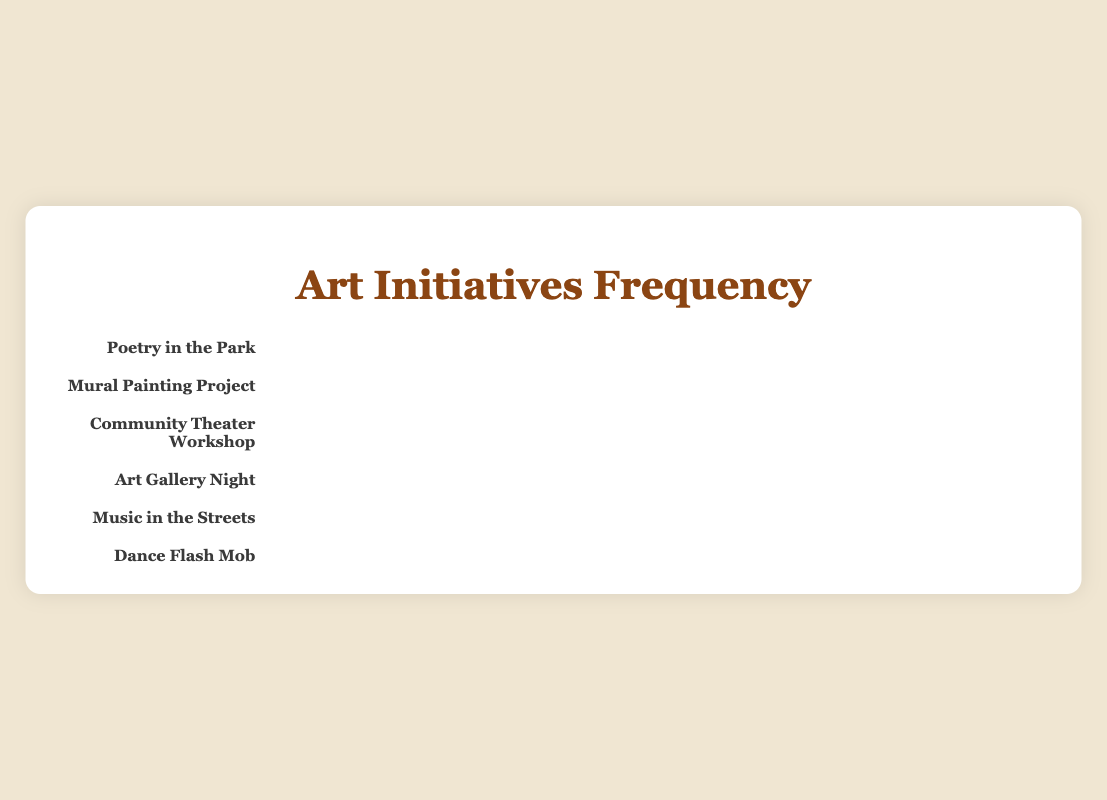What's the title of the plot? The title of the plot is displayed at the top and reads "Art Initiatives Frequency," indicating the plot's focus on the frequency of various art-related initiatives.
Answer: Art Initiatives Frequency Which initiative appears most frequently? By counting the icons for each initiative, "Poetry in the Park" has the most icons with 12 books, indicating it is the most frequent initiative.
Answer: Poetry in the Park How many times does the "Dance Flash Mob" initiative occur? Count the number of dancer icons next to the "Dance Flash Mob" label. There are 3 dancer icons, so it occurs 3 times.
Answer: 3 Which initiative has more frequent events: "Mural Painting Project" or "Art Gallery Night"? By comparing the number of icons, "Mural Painting Project" has 4 paintbrush icons and "Art Gallery Night" has 6 frame icons. Since 6 > 4, "Art Gallery Night" is more frequent.
Answer: Art Gallery Night What's the combined frequency of "Community Theater Workshop" and "Music in the Streets"? Add the number of icons for both initiatives. "Community Theater Workshop" has 8 mask icons, and "Music in the Streets" has 10 musical-note icons. Thus, 8 + 10 = 18.
Answer: 18 Which initiatives occur less than 5 times? Identify the initiatives with fewer than 5 icons: "Mural Painting Project" with 4 paintbrush icons and "Dance Flash Mob" with 3 dancer icons both occur less than 5 times.
Answer: Mural Painting Project and Dance Flash Mob How many icons are there in total for all initiatives combined? Add the number of icons for each initiative: 12 (Poetry) + 4 (Mural) + 8 (Theater) + 6 (Gallery) + 10 (Music) + 3 (Dance) = 43.
Answer: 43 Compare the frequency of "Poetry in the Park" and "Music in the Streets." How many more icons does the former have? Subtract the number of musical-note icons for "Music in the Streets" from the number of book icons for "Poetry in the Park." Poetry has 12 icons and Music has 10, so 12 - 10 = 2.
Answer: 2 What is the average frequency of all the initiatives? Sum the frequencies of all initiatives: 12 (Poetry) + 4 (Mural) + 8 (Theater) + 6 (Gallery) + 10 (Music) + 3 (Dance) = 43. There are 6 initiatives, so the average is 43 / 6 ≈ 7.17.
Answer: 7.17 